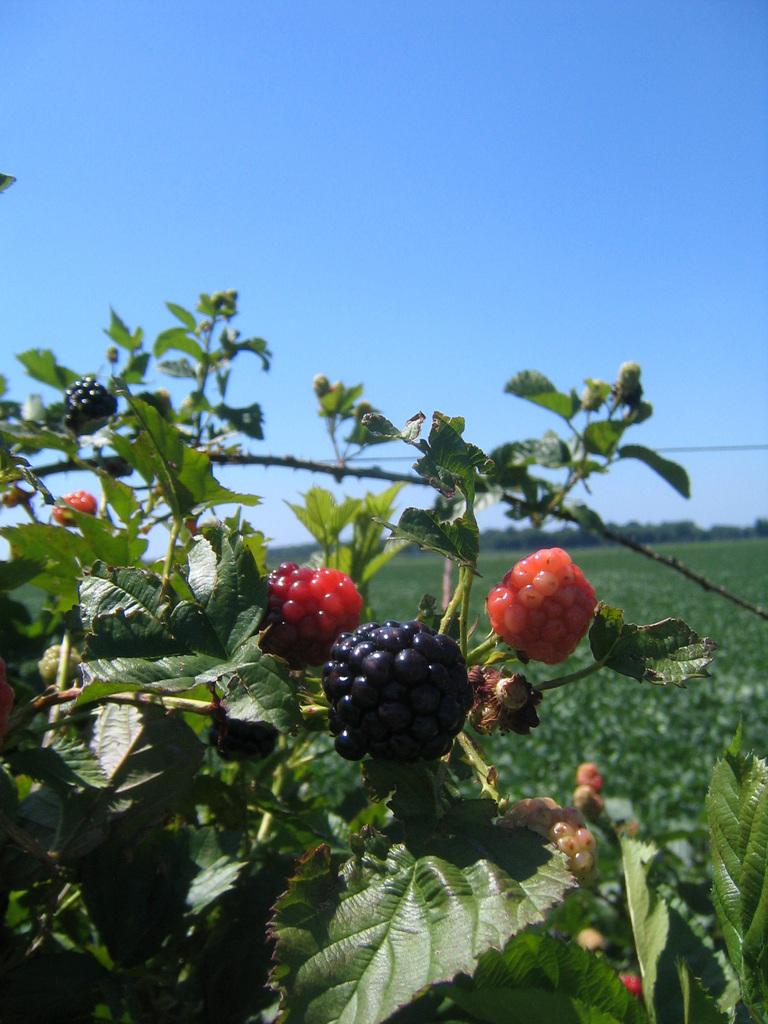What type of produce can be seen on the plants in the image? There are fruits on the plants in the image. What colors are the fruits? The fruits are in black and red colors. What can be seen in the background of the image? There are plants and many trees visible in the background of the image. What color is the sky in the background of the image? The sky is blue in the background of the image. What type of comb is used to harvest the fruits in the image? There is no comb present in the image, and the fruits are not being harvested. 